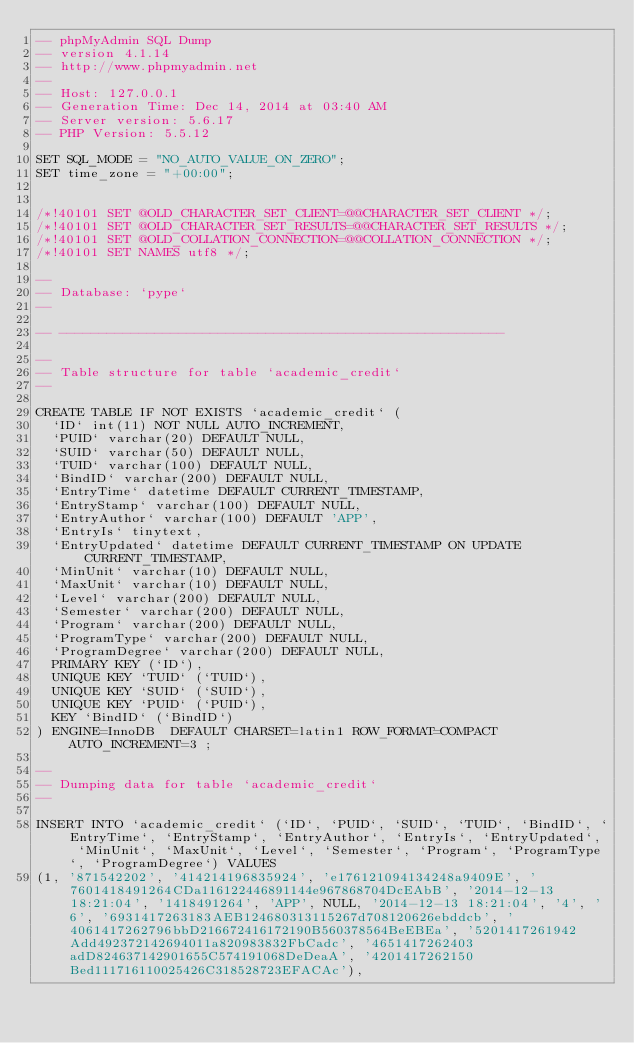Convert code to text. <code><loc_0><loc_0><loc_500><loc_500><_SQL_>-- phpMyAdmin SQL Dump
-- version 4.1.14
-- http://www.phpmyadmin.net
--
-- Host: 127.0.0.1
-- Generation Time: Dec 14, 2014 at 03:40 AM
-- Server version: 5.6.17
-- PHP Version: 5.5.12

SET SQL_MODE = "NO_AUTO_VALUE_ON_ZERO";
SET time_zone = "+00:00";


/*!40101 SET @OLD_CHARACTER_SET_CLIENT=@@CHARACTER_SET_CLIENT */;
/*!40101 SET @OLD_CHARACTER_SET_RESULTS=@@CHARACTER_SET_RESULTS */;
/*!40101 SET @OLD_COLLATION_CONNECTION=@@COLLATION_CONNECTION */;
/*!40101 SET NAMES utf8 */;

--
-- Database: `pype`
--

-- --------------------------------------------------------

--
-- Table structure for table `academic_credit`
--

CREATE TABLE IF NOT EXISTS `academic_credit` (
  `ID` int(11) NOT NULL AUTO_INCREMENT,
  `PUID` varchar(20) DEFAULT NULL,
  `SUID` varchar(50) DEFAULT NULL,
  `TUID` varchar(100) DEFAULT NULL,
  `BindID` varchar(200) DEFAULT NULL,
  `EntryTime` datetime DEFAULT CURRENT_TIMESTAMP,
  `EntryStamp` varchar(100) DEFAULT NULL,
  `EntryAuthor` varchar(100) DEFAULT 'APP',
  `EntryIs` tinytext,
  `EntryUpdated` datetime DEFAULT CURRENT_TIMESTAMP ON UPDATE CURRENT_TIMESTAMP,
  `MinUnit` varchar(10) DEFAULT NULL,
  `MaxUnit` varchar(10) DEFAULT NULL,
  `Level` varchar(200) DEFAULT NULL,
  `Semester` varchar(200) DEFAULT NULL,
  `Program` varchar(200) DEFAULT NULL,
  `ProgramType` varchar(200) DEFAULT NULL,
  `ProgramDegree` varchar(200) DEFAULT NULL,
  PRIMARY KEY (`ID`),
  UNIQUE KEY `TUID` (`TUID`),
  UNIQUE KEY `SUID` (`SUID`),
  UNIQUE KEY `PUID` (`PUID`),
  KEY `BindID` (`BindID`)
) ENGINE=InnoDB  DEFAULT CHARSET=latin1 ROW_FORMAT=COMPACT AUTO_INCREMENT=3 ;

--
-- Dumping data for table `academic_credit`
--

INSERT INTO `academic_credit` (`ID`, `PUID`, `SUID`, `TUID`, `BindID`, `EntryTime`, `EntryStamp`, `EntryAuthor`, `EntryIs`, `EntryUpdated`, `MinUnit`, `MaxUnit`, `Level`, `Semester`, `Program`, `ProgramType`, `ProgramDegree`) VALUES
(1, '871542202', '414214196835924', 'e176121094134248a9409E', '7601418491264CDa116122446891144e967868704DcEAbB', '2014-12-13 18:21:04', '1418491264', 'APP', NULL, '2014-12-13 18:21:04', '4', '6', '6931417263183AEB124680313115267d708120626ebddcb', '4061417262796bbD216672416172190B560378564BeEBEa', '5201417261942Add492372142694011a820983832FbCadc', '4651417262403adD824637142901655C574191068DeDeaA', '4201417262150Bed111716110025426C318528723EFACAc'),</code> 